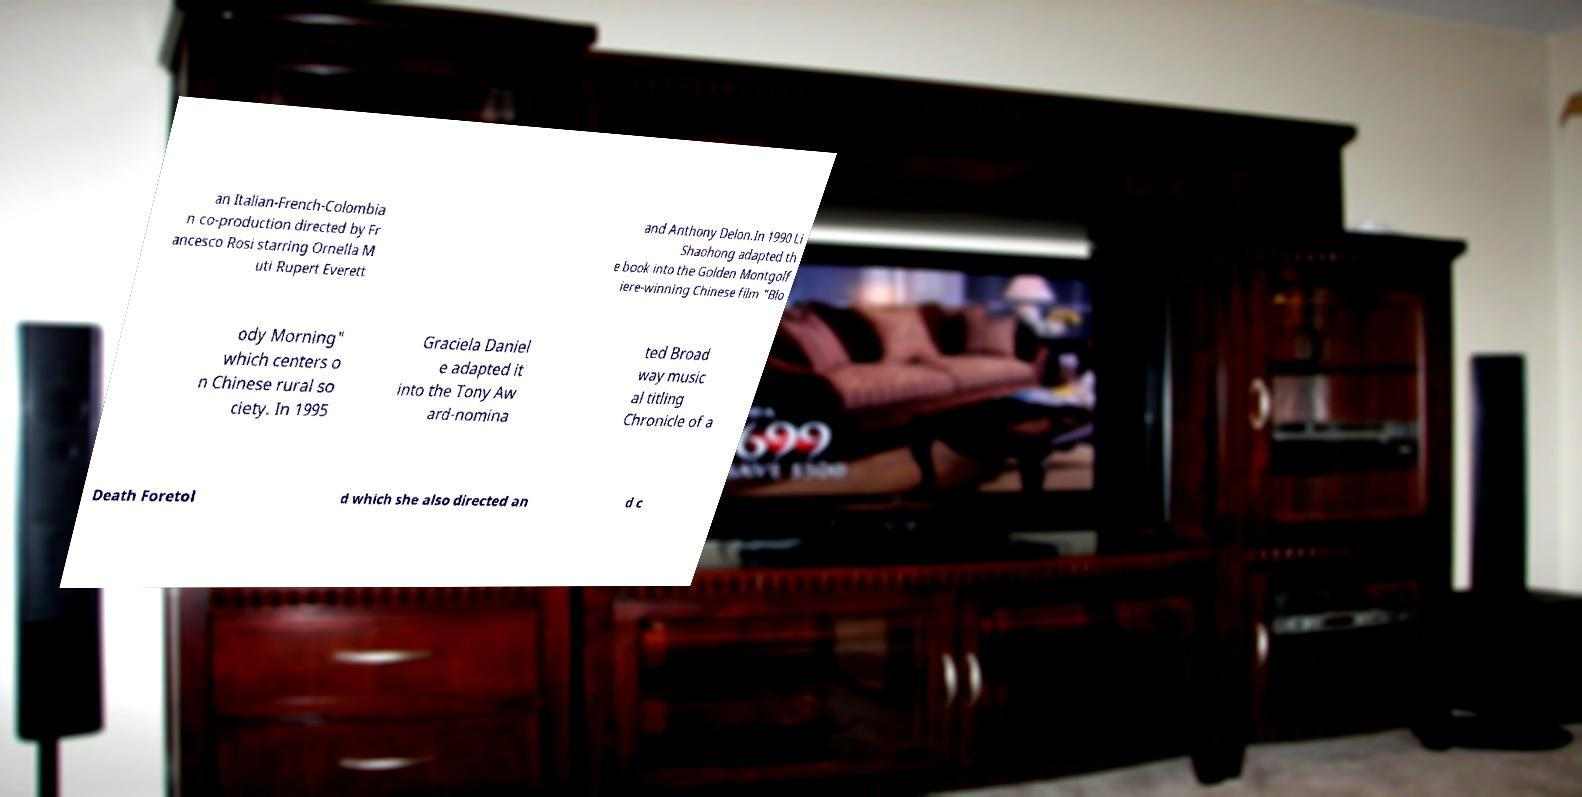Could you extract and type out the text from this image? an Italian-French-Colombia n co-production directed by Fr ancesco Rosi starring Ornella M uti Rupert Everett and Anthony Delon.In 1990 Li Shaohong adapted th e book into the Golden Montgolf iere-winning Chinese film "Blo ody Morning" which centers o n Chinese rural so ciety. In 1995 Graciela Daniel e adapted it into the Tony Aw ard-nomina ted Broad way music al titling Chronicle of a Death Foretol d which she also directed an d c 